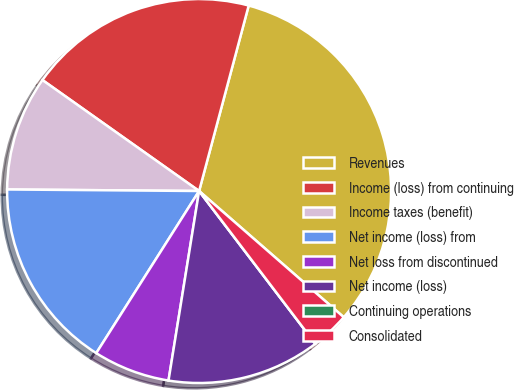Convert chart to OTSL. <chart><loc_0><loc_0><loc_500><loc_500><pie_chart><fcel>Revenues<fcel>Income (loss) from continuing<fcel>Income taxes (benefit)<fcel>Net income (loss) from<fcel>Net loss from discontinued<fcel>Net income (loss)<fcel>Continuing operations<fcel>Consolidated<nl><fcel>32.26%<fcel>19.35%<fcel>9.68%<fcel>16.13%<fcel>6.45%<fcel>12.9%<fcel>0.0%<fcel>3.23%<nl></chart> 